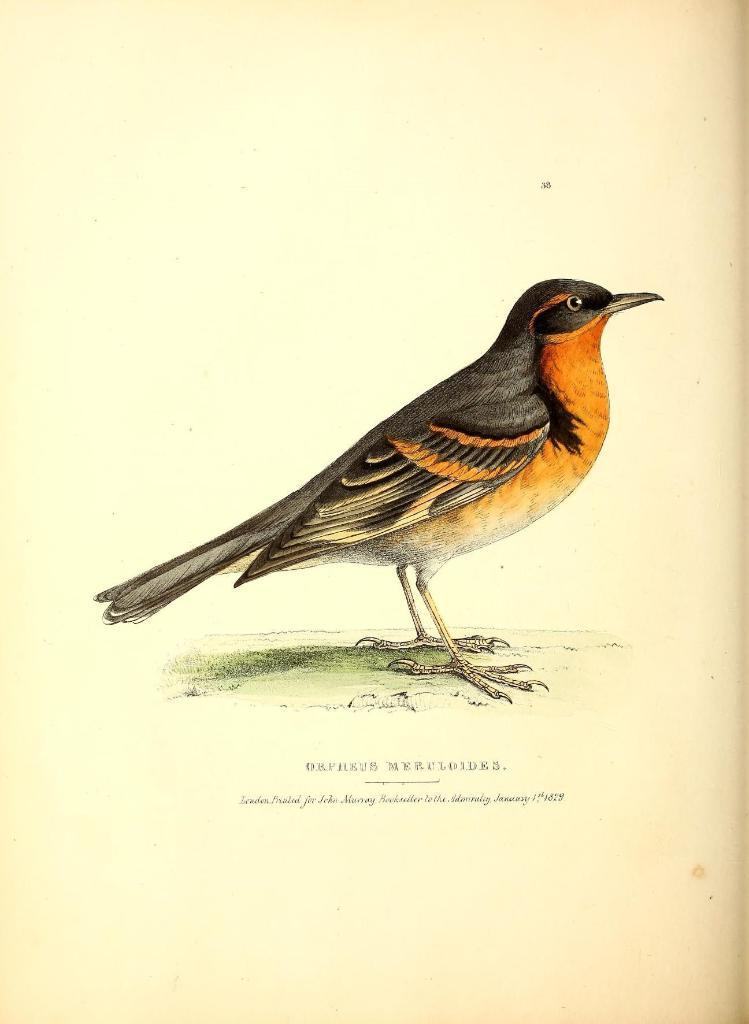What is depicted in the image? There is a picture of a bird in the image. What else can be found in the image besides the bird? There is text written on the image. What hobbies does the bird have in the image? There is no information about the bird's hobbies in the image, as it only shows a picture of a bird and text. 